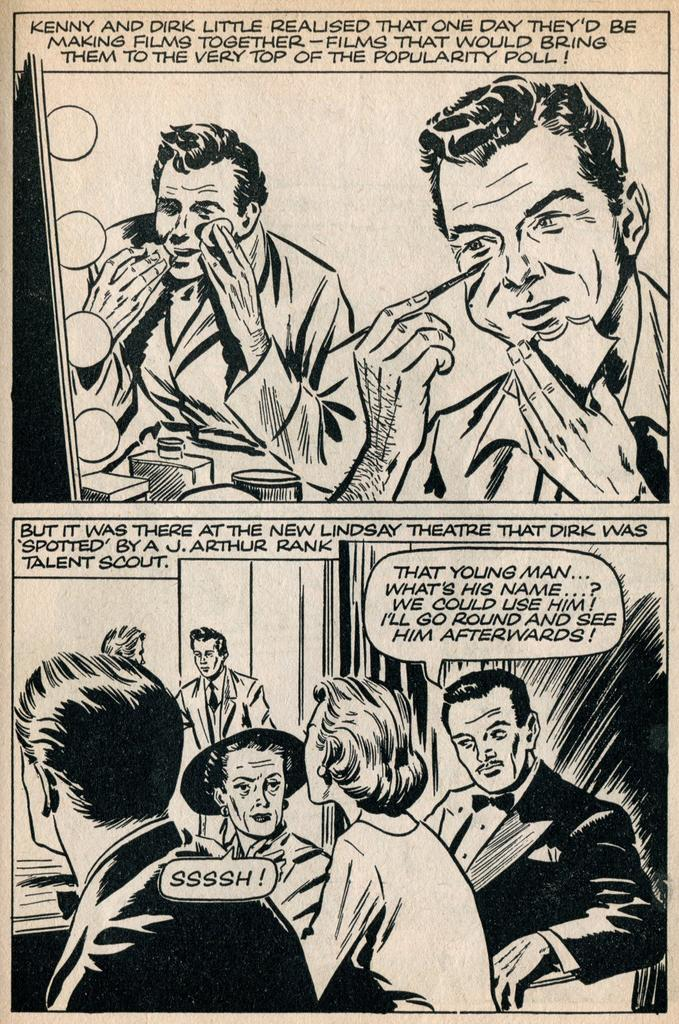<image>
Provide a brief description of the given image. The comic strip features the characters Kenny and Dirk Little. 